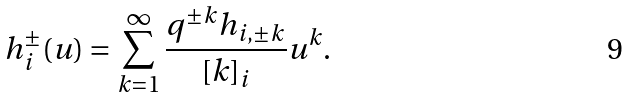Convert formula to latex. <formula><loc_0><loc_0><loc_500><loc_500>h ^ { \pm } _ { i } ( u ) = \sum _ { k = 1 } ^ { \infty } \frac { q ^ { \pm k } h _ { i , \pm k } } { [ k ] _ { i } } u ^ { k } .</formula> 